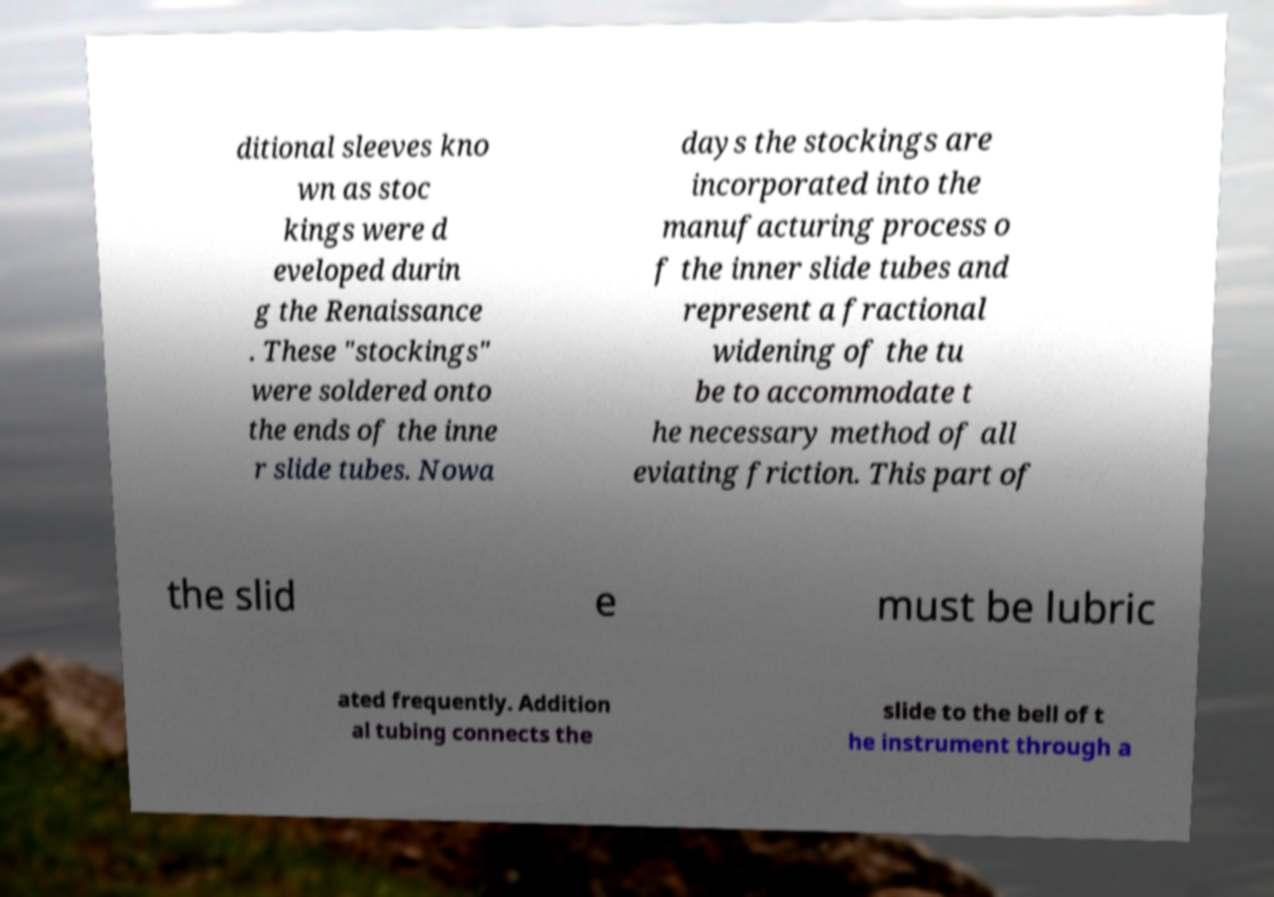Please read and relay the text visible in this image. What does it say? ditional sleeves kno wn as stoc kings were d eveloped durin g the Renaissance . These "stockings" were soldered onto the ends of the inne r slide tubes. Nowa days the stockings are incorporated into the manufacturing process o f the inner slide tubes and represent a fractional widening of the tu be to accommodate t he necessary method of all eviating friction. This part of the slid e must be lubric ated frequently. Addition al tubing connects the slide to the bell of t he instrument through a 